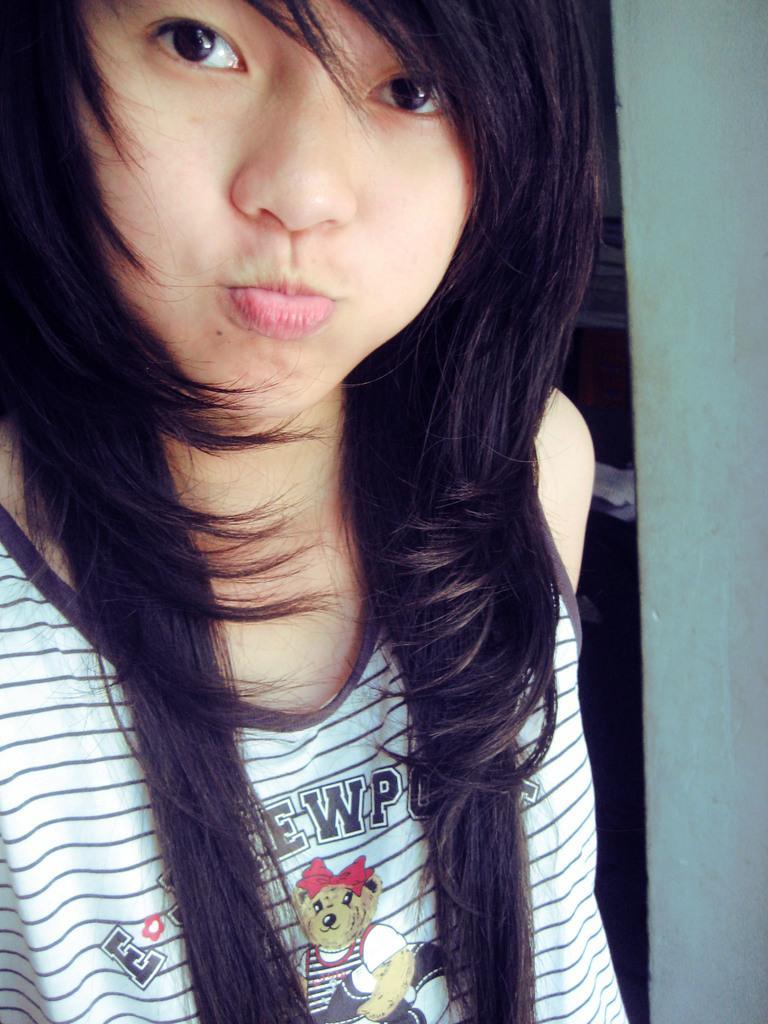Can you describe this image briefly? In this picture there is a woman. In the background of the image we can see wall. 